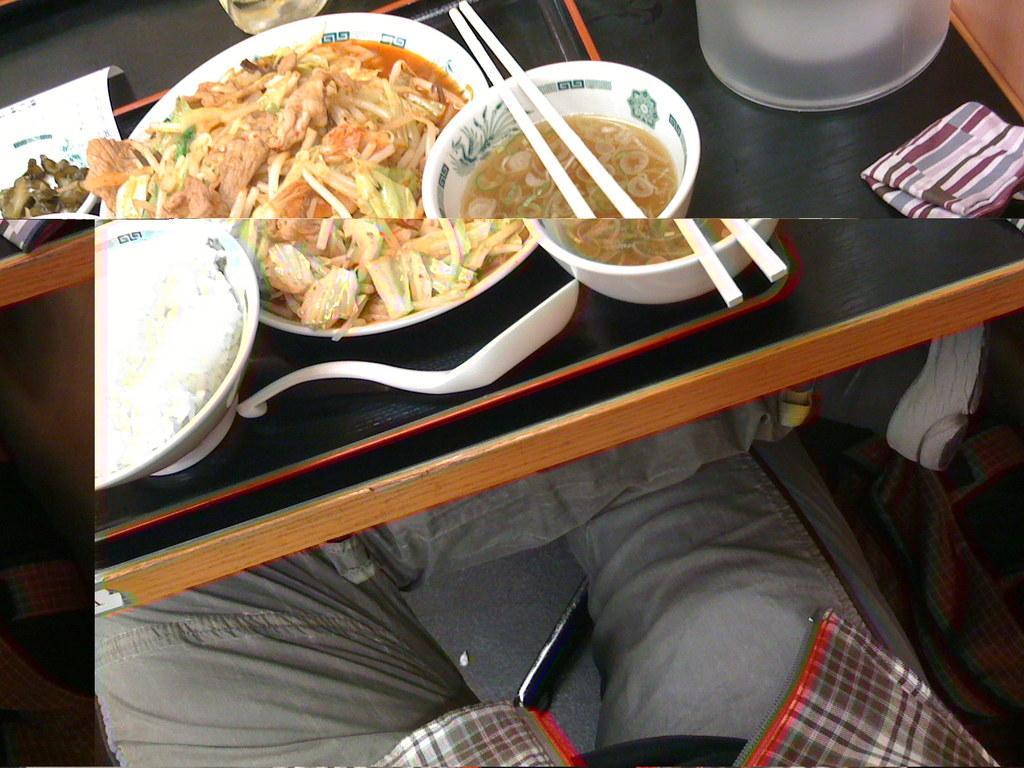Please provide a concise description of this image. Food is highlighted in this picture. On table there are bowls, spoon, plates, chopstick and food. Person is sitting on chair. 